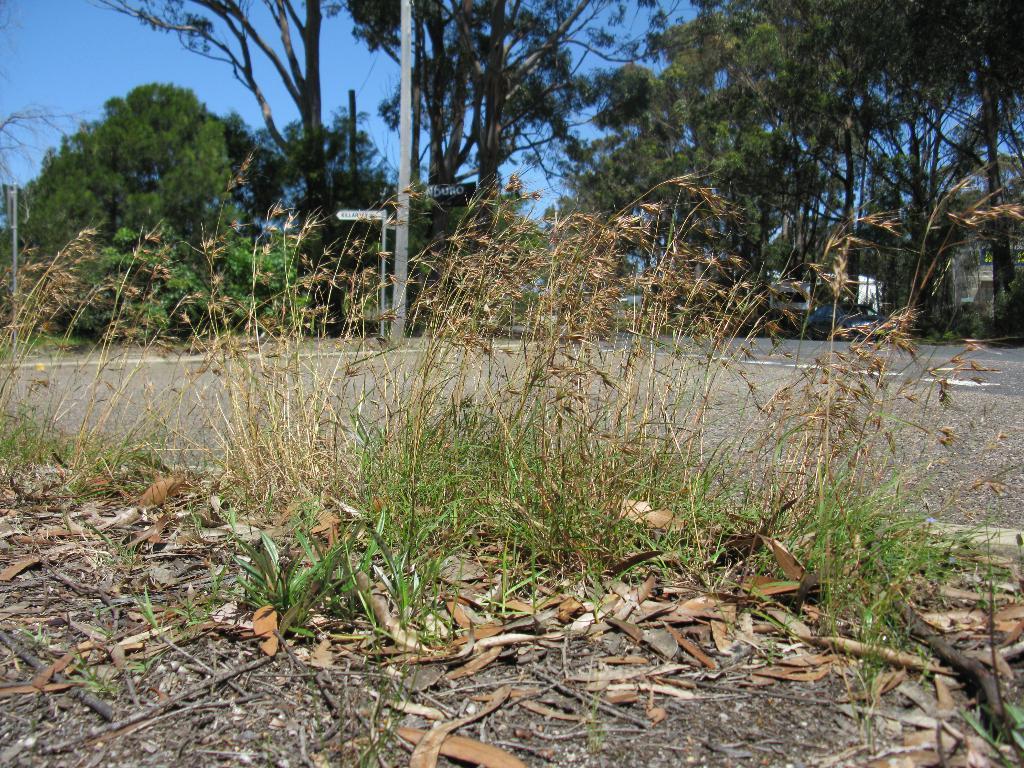Describe this image in one or two sentences. In this picture we can see plants, leaves and road. In the background of the image we can see boards attached to the poles, trees and sky. 